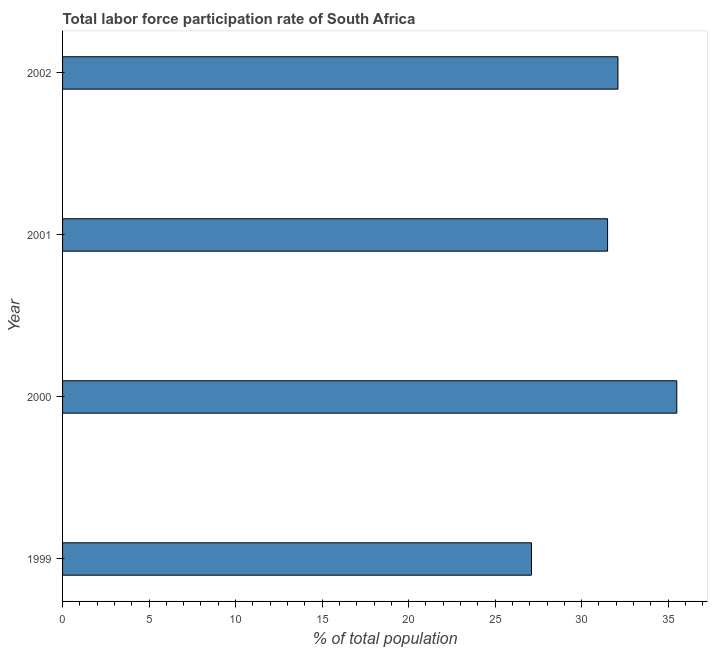What is the title of the graph?
Ensure brevity in your answer.  Total labor force participation rate of South Africa. What is the label or title of the X-axis?
Offer a terse response. % of total population. What is the label or title of the Y-axis?
Your answer should be very brief. Year. What is the total labor force participation rate in 2000?
Keep it short and to the point. 35.5. Across all years, what is the maximum total labor force participation rate?
Provide a succinct answer. 35.5. Across all years, what is the minimum total labor force participation rate?
Give a very brief answer. 27.1. What is the sum of the total labor force participation rate?
Offer a very short reply. 126.2. What is the difference between the total labor force participation rate in 2001 and 2002?
Provide a succinct answer. -0.6. What is the average total labor force participation rate per year?
Provide a succinct answer. 31.55. What is the median total labor force participation rate?
Provide a short and direct response. 31.8. In how many years, is the total labor force participation rate greater than 21 %?
Provide a short and direct response. 4. What is the ratio of the total labor force participation rate in 1999 to that in 2002?
Your answer should be very brief. 0.84. Is the total labor force participation rate in 1999 less than that in 2002?
Ensure brevity in your answer.  Yes. What is the difference between the highest and the second highest total labor force participation rate?
Your answer should be compact. 3.4. What is the difference between the highest and the lowest total labor force participation rate?
Give a very brief answer. 8.4. How many bars are there?
Your answer should be compact. 4. Are all the bars in the graph horizontal?
Provide a short and direct response. Yes. Are the values on the major ticks of X-axis written in scientific E-notation?
Provide a succinct answer. No. What is the % of total population in 1999?
Ensure brevity in your answer.  27.1. What is the % of total population of 2000?
Offer a terse response. 35.5. What is the % of total population of 2001?
Your answer should be very brief. 31.5. What is the % of total population of 2002?
Offer a very short reply. 32.1. What is the difference between the % of total population in 1999 and 2000?
Give a very brief answer. -8.4. What is the difference between the % of total population in 1999 and 2002?
Offer a terse response. -5. What is the ratio of the % of total population in 1999 to that in 2000?
Your answer should be very brief. 0.76. What is the ratio of the % of total population in 1999 to that in 2001?
Provide a short and direct response. 0.86. What is the ratio of the % of total population in 1999 to that in 2002?
Ensure brevity in your answer.  0.84. What is the ratio of the % of total population in 2000 to that in 2001?
Provide a succinct answer. 1.13. What is the ratio of the % of total population in 2000 to that in 2002?
Offer a very short reply. 1.11. What is the ratio of the % of total population in 2001 to that in 2002?
Make the answer very short. 0.98. 